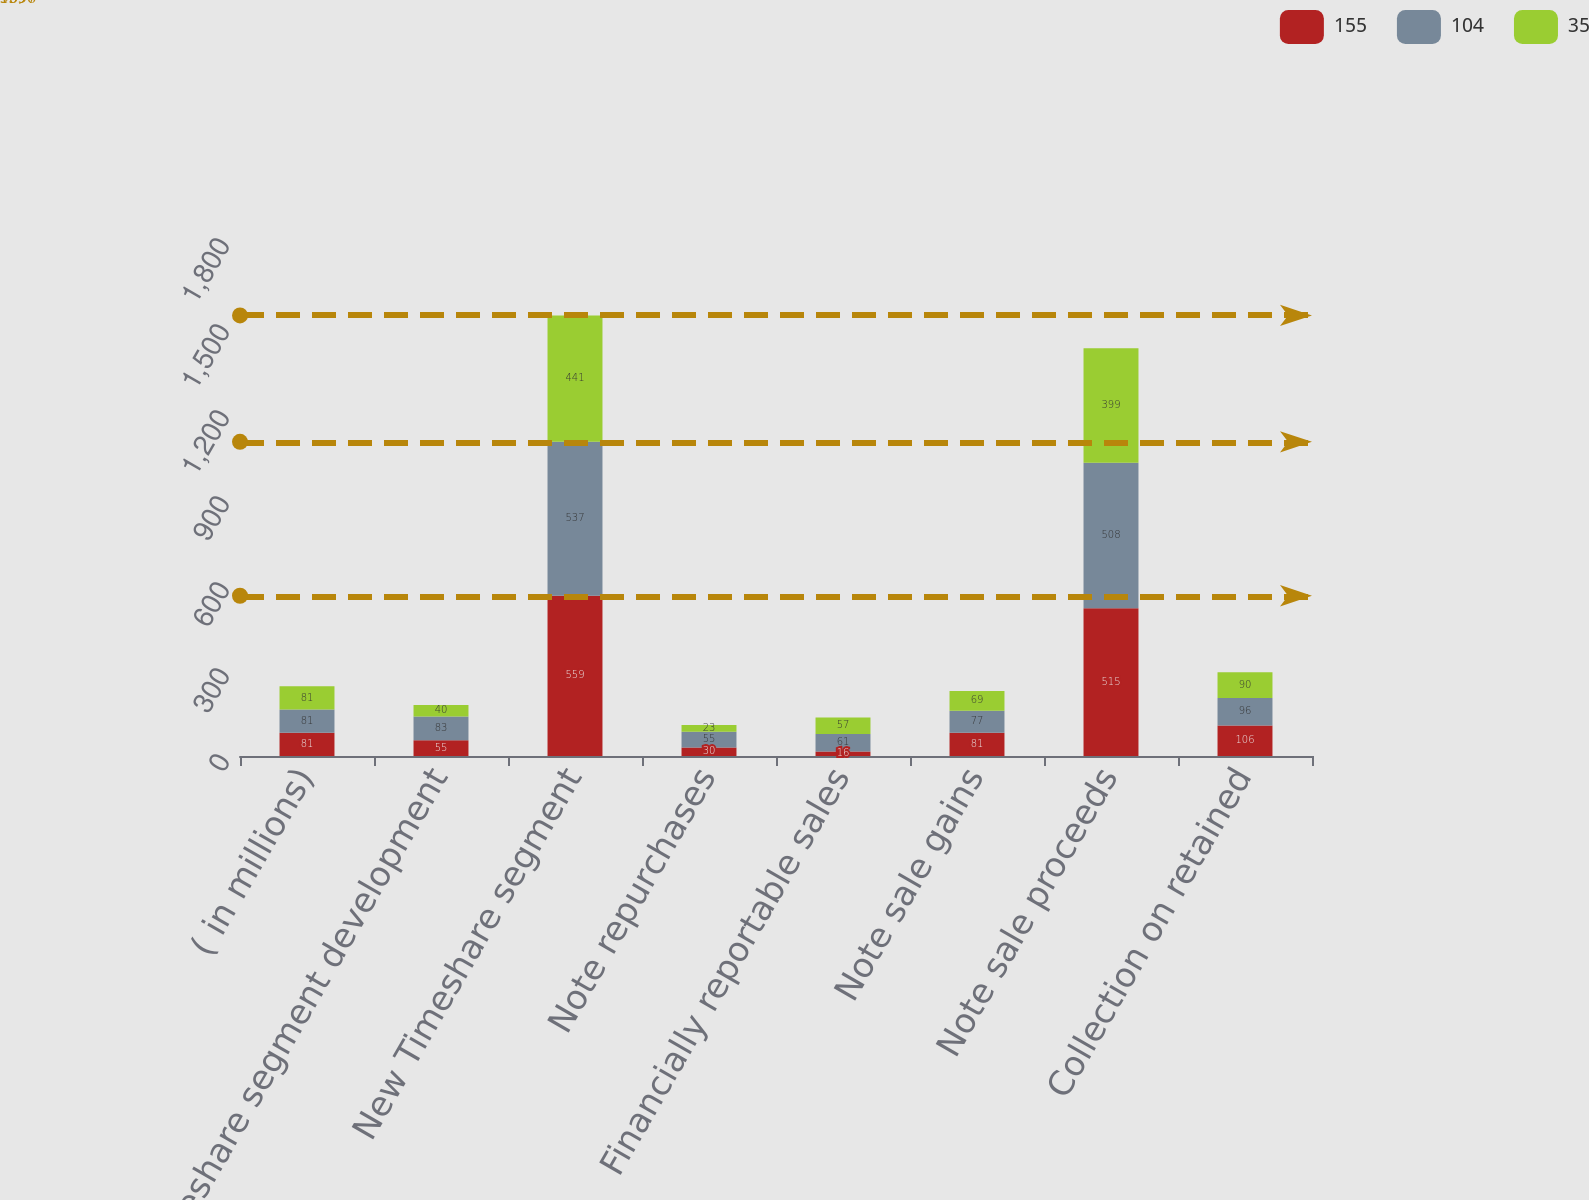<chart> <loc_0><loc_0><loc_500><loc_500><stacked_bar_chart><ecel><fcel>( in millions)<fcel>Timeshare segment development<fcel>New Timeshare segment<fcel>Note repurchases<fcel>Financially reportable sales<fcel>Note sale gains<fcel>Note sale proceeds<fcel>Collection on retained<nl><fcel>155<fcel>81<fcel>55<fcel>559<fcel>30<fcel>16<fcel>81<fcel>515<fcel>106<nl><fcel>104<fcel>81<fcel>83<fcel>537<fcel>55<fcel>61<fcel>77<fcel>508<fcel>96<nl><fcel>35<fcel>81<fcel>40<fcel>441<fcel>23<fcel>57<fcel>69<fcel>399<fcel>90<nl></chart> 